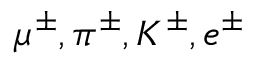<formula> <loc_0><loc_0><loc_500><loc_500>\mu ^ { \pm } , \pi ^ { \pm } , K ^ { \pm } , e ^ { \pm }</formula> 